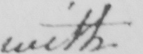What text is written in this handwritten line? with 